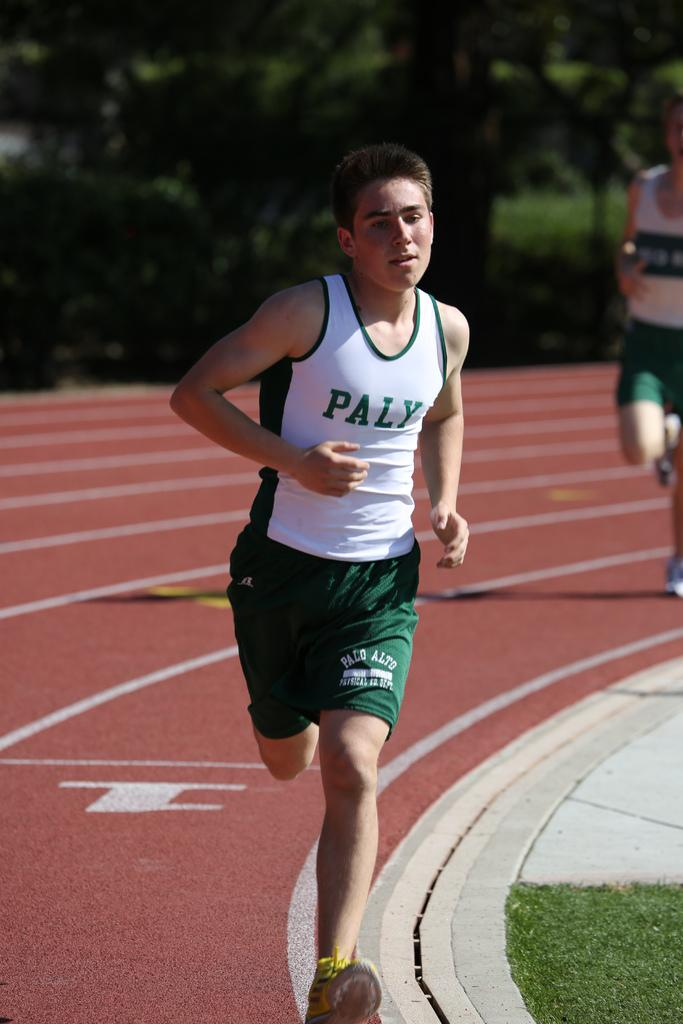How many people are in the image? There are two persons in the image. What are the persons doing in the image? The persons are running. What can be seen in the background of the image? There are trees in the background of the image. What type of doll is being used by the persons in the image? There is no doll present in the image; the persons are running. What brand of toothpaste is being advertised in the image? There is no toothpaste or advertisement present in the image; it features two persons running. 